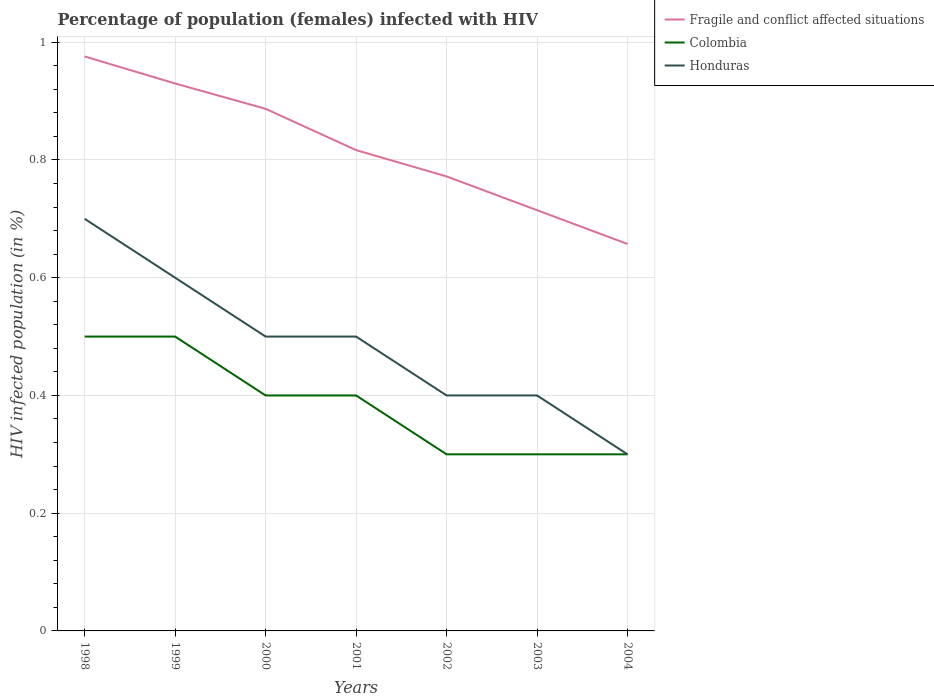Does the line corresponding to Fragile and conflict affected situations intersect with the line corresponding to Colombia?
Make the answer very short. No. Across all years, what is the maximum percentage of HIV infected female population in Colombia?
Keep it short and to the point. 0.3. What is the total percentage of HIV infected female population in Fragile and conflict affected situations in the graph?
Provide a succinct answer. 0.11. What is the difference between the highest and the second highest percentage of HIV infected female population in Honduras?
Your answer should be compact. 0.4. Is the percentage of HIV infected female population in Honduras strictly greater than the percentage of HIV infected female population in Fragile and conflict affected situations over the years?
Provide a short and direct response. Yes. How many lines are there?
Offer a very short reply. 3. How many years are there in the graph?
Make the answer very short. 7. What is the difference between two consecutive major ticks on the Y-axis?
Provide a succinct answer. 0.2. How many legend labels are there?
Offer a terse response. 3. What is the title of the graph?
Keep it short and to the point. Percentage of population (females) infected with HIV. Does "Vanuatu" appear as one of the legend labels in the graph?
Make the answer very short. No. What is the label or title of the Y-axis?
Provide a succinct answer. HIV infected population (in %). What is the HIV infected population (in %) in Fragile and conflict affected situations in 1998?
Your answer should be compact. 0.98. What is the HIV infected population (in %) in Colombia in 1998?
Your answer should be very brief. 0.5. What is the HIV infected population (in %) in Fragile and conflict affected situations in 1999?
Keep it short and to the point. 0.93. What is the HIV infected population (in %) in Colombia in 1999?
Give a very brief answer. 0.5. What is the HIV infected population (in %) in Honduras in 1999?
Make the answer very short. 0.6. What is the HIV infected population (in %) of Fragile and conflict affected situations in 2000?
Your response must be concise. 0.89. What is the HIV infected population (in %) in Colombia in 2000?
Give a very brief answer. 0.4. What is the HIV infected population (in %) in Honduras in 2000?
Ensure brevity in your answer.  0.5. What is the HIV infected population (in %) in Fragile and conflict affected situations in 2001?
Your answer should be compact. 0.82. What is the HIV infected population (in %) in Colombia in 2001?
Offer a very short reply. 0.4. What is the HIV infected population (in %) of Honduras in 2001?
Your answer should be compact. 0.5. What is the HIV infected population (in %) of Fragile and conflict affected situations in 2002?
Ensure brevity in your answer.  0.77. What is the HIV infected population (in %) of Colombia in 2002?
Give a very brief answer. 0.3. What is the HIV infected population (in %) in Honduras in 2002?
Offer a very short reply. 0.4. What is the HIV infected population (in %) of Fragile and conflict affected situations in 2003?
Your answer should be very brief. 0.71. What is the HIV infected population (in %) in Colombia in 2003?
Your response must be concise. 0.3. What is the HIV infected population (in %) in Honduras in 2003?
Make the answer very short. 0.4. What is the HIV infected population (in %) in Fragile and conflict affected situations in 2004?
Make the answer very short. 0.66. What is the HIV infected population (in %) of Honduras in 2004?
Offer a very short reply. 0.3. Across all years, what is the maximum HIV infected population (in %) in Fragile and conflict affected situations?
Offer a very short reply. 0.98. Across all years, what is the maximum HIV infected population (in %) of Colombia?
Offer a very short reply. 0.5. Across all years, what is the minimum HIV infected population (in %) of Fragile and conflict affected situations?
Your response must be concise. 0.66. Across all years, what is the minimum HIV infected population (in %) in Honduras?
Keep it short and to the point. 0.3. What is the total HIV infected population (in %) in Fragile and conflict affected situations in the graph?
Provide a short and direct response. 5.75. What is the total HIV infected population (in %) in Colombia in the graph?
Offer a very short reply. 2.7. What is the difference between the HIV infected population (in %) of Fragile and conflict affected situations in 1998 and that in 1999?
Make the answer very short. 0.05. What is the difference between the HIV infected population (in %) of Colombia in 1998 and that in 1999?
Your response must be concise. 0. What is the difference between the HIV infected population (in %) in Fragile and conflict affected situations in 1998 and that in 2000?
Ensure brevity in your answer.  0.09. What is the difference between the HIV infected population (in %) of Fragile and conflict affected situations in 1998 and that in 2001?
Provide a short and direct response. 0.16. What is the difference between the HIV infected population (in %) of Colombia in 1998 and that in 2001?
Make the answer very short. 0.1. What is the difference between the HIV infected population (in %) of Fragile and conflict affected situations in 1998 and that in 2002?
Offer a very short reply. 0.2. What is the difference between the HIV infected population (in %) of Fragile and conflict affected situations in 1998 and that in 2003?
Ensure brevity in your answer.  0.26. What is the difference between the HIV infected population (in %) in Fragile and conflict affected situations in 1998 and that in 2004?
Provide a succinct answer. 0.32. What is the difference between the HIV infected population (in %) of Colombia in 1998 and that in 2004?
Your answer should be compact. 0.2. What is the difference between the HIV infected population (in %) of Honduras in 1998 and that in 2004?
Keep it short and to the point. 0.4. What is the difference between the HIV infected population (in %) of Fragile and conflict affected situations in 1999 and that in 2000?
Ensure brevity in your answer.  0.04. What is the difference between the HIV infected population (in %) of Colombia in 1999 and that in 2000?
Provide a short and direct response. 0.1. What is the difference between the HIV infected population (in %) of Honduras in 1999 and that in 2000?
Provide a succinct answer. 0.1. What is the difference between the HIV infected population (in %) in Fragile and conflict affected situations in 1999 and that in 2001?
Provide a succinct answer. 0.11. What is the difference between the HIV infected population (in %) in Fragile and conflict affected situations in 1999 and that in 2002?
Offer a terse response. 0.16. What is the difference between the HIV infected population (in %) in Fragile and conflict affected situations in 1999 and that in 2003?
Provide a short and direct response. 0.22. What is the difference between the HIV infected population (in %) of Honduras in 1999 and that in 2003?
Your answer should be very brief. 0.2. What is the difference between the HIV infected population (in %) of Fragile and conflict affected situations in 1999 and that in 2004?
Your response must be concise. 0.27. What is the difference between the HIV infected population (in %) of Colombia in 1999 and that in 2004?
Provide a short and direct response. 0.2. What is the difference between the HIV infected population (in %) in Fragile and conflict affected situations in 2000 and that in 2001?
Provide a short and direct response. 0.07. What is the difference between the HIV infected population (in %) in Colombia in 2000 and that in 2001?
Offer a terse response. 0. What is the difference between the HIV infected population (in %) of Honduras in 2000 and that in 2001?
Make the answer very short. 0. What is the difference between the HIV infected population (in %) of Fragile and conflict affected situations in 2000 and that in 2002?
Give a very brief answer. 0.11. What is the difference between the HIV infected population (in %) of Fragile and conflict affected situations in 2000 and that in 2003?
Your response must be concise. 0.17. What is the difference between the HIV infected population (in %) of Honduras in 2000 and that in 2003?
Give a very brief answer. 0.1. What is the difference between the HIV infected population (in %) in Fragile and conflict affected situations in 2000 and that in 2004?
Offer a very short reply. 0.23. What is the difference between the HIV infected population (in %) in Fragile and conflict affected situations in 2001 and that in 2002?
Your answer should be very brief. 0.04. What is the difference between the HIV infected population (in %) of Honduras in 2001 and that in 2002?
Your answer should be very brief. 0.1. What is the difference between the HIV infected population (in %) of Fragile and conflict affected situations in 2001 and that in 2003?
Provide a succinct answer. 0.1. What is the difference between the HIV infected population (in %) of Honduras in 2001 and that in 2003?
Your answer should be compact. 0.1. What is the difference between the HIV infected population (in %) in Fragile and conflict affected situations in 2001 and that in 2004?
Keep it short and to the point. 0.16. What is the difference between the HIV infected population (in %) in Colombia in 2001 and that in 2004?
Make the answer very short. 0.1. What is the difference between the HIV infected population (in %) in Fragile and conflict affected situations in 2002 and that in 2003?
Give a very brief answer. 0.06. What is the difference between the HIV infected population (in %) in Colombia in 2002 and that in 2003?
Make the answer very short. 0. What is the difference between the HIV infected population (in %) of Fragile and conflict affected situations in 2002 and that in 2004?
Provide a short and direct response. 0.11. What is the difference between the HIV infected population (in %) of Colombia in 2002 and that in 2004?
Offer a terse response. 0. What is the difference between the HIV infected population (in %) in Honduras in 2002 and that in 2004?
Your response must be concise. 0.1. What is the difference between the HIV infected population (in %) in Fragile and conflict affected situations in 2003 and that in 2004?
Ensure brevity in your answer.  0.06. What is the difference between the HIV infected population (in %) of Fragile and conflict affected situations in 1998 and the HIV infected population (in %) of Colombia in 1999?
Provide a short and direct response. 0.48. What is the difference between the HIV infected population (in %) in Fragile and conflict affected situations in 1998 and the HIV infected population (in %) in Honduras in 1999?
Make the answer very short. 0.38. What is the difference between the HIV infected population (in %) of Colombia in 1998 and the HIV infected population (in %) of Honduras in 1999?
Provide a short and direct response. -0.1. What is the difference between the HIV infected population (in %) of Fragile and conflict affected situations in 1998 and the HIV infected population (in %) of Colombia in 2000?
Offer a very short reply. 0.58. What is the difference between the HIV infected population (in %) in Fragile and conflict affected situations in 1998 and the HIV infected population (in %) in Honduras in 2000?
Make the answer very short. 0.48. What is the difference between the HIV infected population (in %) of Fragile and conflict affected situations in 1998 and the HIV infected population (in %) of Colombia in 2001?
Your answer should be very brief. 0.58. What is the difference between the HIV infected population (in %) of Fragile and conflict affected situations in 1998 and the HIV infected population (in %) of Honduras in 2001?
Offer a terse response. 0.48. What is the difference between the HIV infected population (in %) of Colombia in 1998 and the HIV infected population (in %) of Honduras in 2001?
Give a very brief answer. 0. What is the difference between the HIV infected population (in %) in Fragile and conflict affected situations in 1998 and the HIV infected population (in %) in Colombia in 2002?
Offer a terse response. 0.68. What is the difference between the HIV infected population (in %) of Fragile and conflict affected situations in 1998 and the HIV infected population (in %) of Honduras in 2002?
Keep it short and to the point. 0.58. What is the difference between the HIV infected population (in %) in Fragile and conflict affected situations in 1998 and the HIV infected population (in %) in Colombia in 2003?
Your answer should be compact. 0.68. What is the difference between the HIV infected population (in %) in Fragile and conflict affected situations in 1998 and the HIV infected population (in %) in Honduras in 2003?
Keep it short and to the point. 0.58. What is the difference between the HIV infected population (in %) of Fragile and conflict affected situations in 1998 and the HIV infected population (in %) of Colombia in 2004?
Ensure brevity in your answer.  0.68. What is the difference between the HIV infected population (in %) of Fragile and conflict affected situations in 1998 and the HIV infected population (in %) of Honduras in 2004?
Your answer should be compact. 0.68. What is the difference between the HIV infected population (in %) of Fragile and conflict affected situations in 1999 and the HIV infected population (in %) of Colombia in 2000?
Provide a short and direct response. 0.53. What is the difference between the HIV infected population (in %) in Fragile and conflict affected situations in 1999 and the HIV infected population (in %) in Honduras in 2000?
Your response must be concise. 0.43. What is the difference between the HIV infected population (in %) of Fragile and conflict affected situations in 1999 and the HIV infected population (in %) of Colombia in 2001?
Your response must be concise. 0.53. What is the difference between the HIV infected population (in %) of Fragile and conflict affected situations in 1999 and the HIV infected population (in %) of Honduras in 2001?
Your answer should be very brief. 0.43. What is the difference between the HIV infected population (in %) of Fragile and conflict affected situations in 1999 and the HIV infected population (in %) of Colombia in 2002?
Provide a short and direct response. 0.63. What is the difference between the HIV infected population (in %) of Fragile and conflict affected situations in 1999 and the HIV infected population (in %) of Honduras in 2002?
Keep it short and to the point. 0.53. What is the difference between the HIV infected population (in %) in Fragile and conflict affected situations in 1999 and the HIV infected population (in %) in Colombia in 2003?
Your answer should be very brief. 0.63. What is the difference between the HIV infected population (in %) of Fragile and conflict affected situations in 1999 and the HIV infected population (in %) of Honduras in 2003?
Provide a succinct answer. 0.53. What is the difference between the HIV infected population (in %) in Colombia in 1999 and the HIV infected population (in %) in Honduras in 2003?
Your answer should be compact. 0.1. What is the difference between the HIV infected population (in %) in Fragile and conflict affected situations in 1999 and the HIV infected population (in %) in Colombia in 2004?
Keep it short and to the point. 0.63. What is the difference between the HIV infected population (in %) in Fragile and conflict affected situations in 1999 and the HIV infected population (in %) in Honduras in 2004?
Keep it short and to the point. 0.63. What is the difference between the HIV infected population (in %) of Fragile and conflict affected situations in 2000 and the HIV infected population (in %) of Colombia in 2001?
Offer a very short reply. 0.49. What is the difference between the HIV infected population (in %) of Fragile and conflict affected situations in 2000 and the HIV infected population (in %) of Honduras in 2001?
Provide a succinct answer. 0.39. What is the difference between the HIV infected population (in %) of Colombia in 2000 and the HIV infected population (in %) of Honduras in 2001?
Provide a short and direct response. -0.1. What is the difference between the HIV infected population (in %) of Fragile and conflict affected situations in 2000 and the HIV infected population (in %) of Colombia in 2002?
Provide a succinct answer. 0.59. What is the difference between the HIV infected population (in %) in Fragile and conflict affected situations in 2000 and the HIV infected population (in %) in Honduras in 2002?
Your answer should be very brief. 0.49. What is the difference between the HIV infected population (in %) in Fragile and conflict affected situations in 2000 and the HIV infected population (in %) in Colombia in 2003?
Offer a terse response. 0.59. What is the difference between the HIV infected population (in %) of Fragile and conflict affected situations in 2000 and the HIV infected population (in %) of Honduras in 2003?
Provide a short and direct response. 0.49. What is the difference between the HIV infected population (in %) of Fragile and conflict affected situations in 2000 and the HIV infected population (in %) of Colombia in 2004?
Your response must be concise. 0.59. What is the difference between the HIV infected population (in %) of Fragile and conflict affected situations in 2000 and the HIV infected population (in %) of Honduras in 2004?
Offer a terse response. 0.59. What is the difference between the HIV infected population (in %) in Colombia in 2000 and the HIV infected population (in %) in Honduras in 2004?
Your response must be concise. 0.1. What is the difference between the HIV infected population (in %) of Fragile and conflict affected situations in 2001 and the HIV infected population (in %) of Colombia in 2002?
Ensure brevity in your answer.  0.52. What is the difference between the HIV infected population (in %) of Fragile and conflict affected situations in 2001 and the HIV infected population (in %) of Honduras in 2002?
Give a very brief answer. 0.42. What is the difference between the HIV infected population (in %) of Colombia in 2001 and the HIV infected population (in %) of Honduras in 2002?
Provide a succinct answer. 0. What is the difference between the HIV infected population (in %) in Fragile and conflict affected situations in 2001 and the HIV infected population (in %) in Colombia in 2003?
Offer a very short reply. 0.52. What is the difference between the HIV infected population (in %) of Fragile and conflict affected situations in 2001 and the HIV infected population (in %) of Honduras in 2003?
Provide a succinct answer. 0.42. What is the difference between the HIV infected population (in %) in Fragile and conflict affected situations in 2001 and the HIV infected population (in %) in Colombia in 2004?
Your answer should be very brief. 0.52. What is the difference between the HIV infected population (in %) in Fragile and conflict affected situations in 2001 and the HIV infected population (in %) in Honduras in 2004?
Ensure brevity in your answer.  0.52. What is the difference between the HIV infected population (in %) of Fragile and conflict affected situations in 2002 and the HIV infected population (in %) of Colombia in 2003?
Your answer should be compact. 0.47. What is the difference between the HIV infected population (in %) in Fragile and conflict affected situations in 2002 and the HIV infected population (in %) in Honduras in 2003?
Give a very brief answer. 0.37. What is the difference between the HIV infected population (in %) of Fragile and conflict affected situations in 2002 and the HIV infected population (in %) of Colombia in 2004?
Give a very brief answer. 0.47. What is the difference between the HIV infected population (in %) in Fragile and conflict affected situations in 2002 and the HIV infected population (in %) in Honduras in 2004?
Your response must be concise. 0.47. What is the difference between the HIV infected population (in %) of Fragile and conflict affected situations in 2003 and the HIV infected population (in %) of Colombia in 2004?
Keep it short and to the point. 0.41. What is the difference between the HIV infected population (in %) in Fragile and conflict affected situations in 2003 and the HIV infected population (in %) in Honduras in 2004?
Provide a succinct answer. 0.41. What is the average HIV infected population (in %) in Fragile and conflict affected situations per year?
Make the answer very short. 0.82. What is the average HIV infected population (in %) of Colombia per year?
Ensure brevity in your answer.  0.39. What is the average HIV infected population (in %) in Honduras per year?
Offer a very short reply. 0.49. In the year 1998, what is the difference between the HIV infected population (in %) of Fragile and conflict affected situations and HIV infected population (in %) of Colombia?
Provide a succinct answer. 0.48. In the year 1998, what is the difference between the HIV infected population (in %) in Fragile and conflict affected situations and HIV infected population (in %) in Honduras?
Your response must be concise. 0.28. In the year 1999, what is the difference between the HIV infected population (in %) of Fragile and conflict affected situations and HIV infected population (in %) of Colombia?
Give a very brief answer. 0.43. In the year 1999, what is the difference between the HIV infected population (in %) in Fragile and conflict affected situations and HIV infected population (in %) in Honduras?
Your answer should be compact. 0.33. In the year 1999, what is the difference between the HIV infected population (in %) of Colombia and HIV infected population (in %) of Honduras?
Give a very brief answer. -0.1. In the year 2000, what is the difference between the HIV infected population (in %) in Fragile and conflict affected situations and HIV infected population (in %) in Colombia?
Your response must be concise. 0.49. In the year 2000, what is the difference between the HIV infected population (in %) of Fragile and conflict affected situations and HIV infected population (in %) of Honduras?
Keep it short and to the point. 0.39. In the year 2001, what is the difference between the HIV infected population (in %) in Fragile and conflict affected situations and HIV infected population (in %) in Colombia?
Your answer should be very brief. 0.42. In the year 2001, what is the difference between the HIV infected population (in %) in Fragile and conflict affected situations and HIV infected population (in %) in Honduras?
Offer a very short reply. 0.32. In the year 2001, what is the difference between the HIV infected population (in %) in Colombia and HIV infected population (in %) in Honduras?
Ensure brevity in your answer.  -0.1. In the year 2002, what is the difference between the HIV infected population (in %) in Fragile and conflict affected situations and HIV infected population (in %) in Colombia?
Offer a terse response. 0.47. In the year 2002, what is the difference between the HIV infected population (in %) in Fragile and conflict affected situations and HIV infected population (in %) in Honduras?
Offer a very short reply. 0.37. In the year 2002, what is the difference between the HIV infected population (in %) in Colombia and HIV infected population (in %) in Honduras?
Your response must be concise. -0.1. In the year 2003, what is the difference between the HIV infected population (in %) in Fragile and conflict affected situations and HIV infected population (in %) in Colombia?
Your answer should be compact. 0.41. In the year 2003, what is the difference between the HIV infected population (in %) in Fragile and conflict affected situations and HIV infected population (in %) in Honduras?
Your response must be concise. 0.31. In the year 2003, what is the difference between the HIV infected population (in %) of Colombia and HIV infected population (in %) of Honduras?
Your answer should be compact. -0.1. In the year 2004, what is the difference between the HIV infected population (in %) of Fragile and conflict affected situations and HIV infected population (in %) of Colombia?
Give a very brief answer. 0.36. In the year 2004, what is the difference between the HIV infected population (in %) in Fragile and conflict affected situations and HIV infected population (in %) in Honduras?
Ensure brevity in your answer.  0.36. In the year 2004, what is the difference between the HIV infected population (in %) of Colombia and HIV infected population (in %) of Honduras?
Keep it short and to the point. 0. What is the ratio of the HIV infected population (in %) of Fragile and conflict affected situations in 1998 to that in 1999?
Your answer should be very brief. 1.05. What is the ratio of the HIV infected population (in %) of Colombia in 1998 to that in 1999?
Your response must be concise. 1. What is the ratio of the HIV infected population (in %) in Fragile and conflict affected situations in 1998 to that in 2000?
Give a very brief answer. 1.1. What is the ratio of the HIV infected population (in %) of Colombia in 1998 to that in 2000?
Offer a very short reply. 1.25. What is the ratio of the HIV infected population (in %) in Honduras in 1998 to that in 2000?
Provide a short and direct response. 1.4. What is the ratio of the HIV infected population (in %) of Fragile and conflict affected situations in 1998 to that in 2001?
Provide a short and direct response. 1.19. What is the ratio of the HIV infected population (in %) of Colombia in 1998 to that in 2001?
Your answer should be very brief. 1.25. What is the ratio of the HIV infected population (in %) of Fragile and conflict affected situations in 1998 to that in 2002?
Provide a succinct answer. 1.26. What is the ratio of the HIV infected population (in %) in Fragile and conflict affected situations in 1998 to that in 2003?
Your answer should be very brief. 1.37. What is the ratio of the HIV infected population (in %) of Fragile and conflict affected situations in 1998 to that in 2004?
Give a very brief answer. 1.48. What is the ratio of the HIV infected population (in %) of Honduras in 1998 to that in 2004?
Offer a very short reply. 2.33. What is the ratio of the HIV infected population (in %) in Fragile and conflict affected situations in 1999 to that in 2000?
Make the answer very short. 1.05. What is the ratio of the HIV infected population (in %) of Fragile and conflict affected situations in 1999 to that in 2001?
Give a very brief answer. 1.14. What is the ratio of the HIV infected population (in %) of Colombia in 1999 to that in 2001?
Provide a succinct answer. 1.25. What is the ratio of the HIV infected population (in %) of Honduras in 1999 to that in 2001?
Keep it short and to the point. 1.2. What is the ratio of the HIV infected population (in %) in Fragile and conflict affected situations in 1999 to that in 2002?
Provide a succinct answer. 1.2. What is the ratio of the HIV infected population (in %) of Honduras in 1999 to that in 2002?
Your answer should be compact. 1.5. What is the ratio of the HIV infected population (in %) in Fragile and conflict affected situations in 1999 to that in 2003?
Your answer should be compact. 1.3. What is the ratio of the HIV infected population (in %) of Colombia in 1999 to that in 2003?
Your response must be concise. 1.67. What is the ratio of the HIV infected population (in %) of Honduras in 1999 to that in 2003?
Your response must be concise. 1.5. What is the ratio of the HIV infected population (in %) of Fragile and conflict affected situations in 1999 to that in 2004?
Ensure brevity in your answer.  1.41. What is the ratio of the HIV infected population (in %) in Honduras in 1999 to that in 2004?
Make the answer very short. 2. What is the ratio of the HIV infected population (in %) in Fragile and conflict affected situations in 2000 to that in 2001?
Offer a very short reply. 1.09. What is the ratio of the HIV infected population (in %) in Colombia in 2000 to that in 2001?
Provide a short and direct response. 1. What is the ratio of the HIV infected population (in %) in Fragile and conflict affected situations in 2000 to that in 2002?
Provide a short and direct response. 1.15. What is the ratio of the HIV infected population (in %) of Colombia in 2000 to that in 2002?
Your answer should be very brief. 1.33. What is the ratio of the HIV infected population (in %) in Honduras in 2000 to that in 2002?
Your answer should be very brief. 1.25. What is the ratio of the HIV infected population (in %) in Fragile and conflict affected situations in 2000 to that in 2003?
Make the answer very short. 1.24. What is the ratio of the HIV infected population (in %) in Colombia in 2000 to that in 2003?
Your answer should be compact. 1.33. What is the ratio of the HIV infected population (in %) in Honduras in 2000 to that in 2003?
Make the answer very short. 1.25. What is the ratio of the HIV infected population (in %) in Fragile and conflict affected situations in 2000 to that in 2004?
Give a very brief answer. 1.35. What is the ratio of the HIV infected population (in %) in Fragile and conflict affected situations in 2001 to that in 2002?
Offer a terse response. 1.06. What is the ratio of the HIV infected population (in %) in Fragile and conflict affected situations in 2001 to that in 2003?
Keep it short and to the point. 1.14. What is the ratio of the HIV infected population (in %) of Fragile and conflict affected situations in 2001 to that in 2004?
Make the answer very short. 1.24. What is the ratio of the HIV infected population (in %) of Honduras in 2001 to that in 2004?
Offer a terse response. 1.67. What is the ratio of the HIV infected population (in %) of Fragile and conflict affected situations in 2002 to that in 2003?
Your answer should be very brief. 1.08. What is the ratio of the HIV infected population (in %) in Honduras in 2002 to that in 2003?
Offer a terse response. 1. What is the ratio of the HIV infected population (in %) in Fragile and conflict affected situations in 2002 to that in 2004?
Your answer should be very brief. 1.17. What is the ratio of the HIV infected population (in %) of Colombia in 2002 to that in 2004?
Your answer should be very brief. 1. What is the ratio of the HIV infected population (in %) of Fragile and conflict affected situations in 2003 to that in 2004?
Your response must be concise. 1.09. What is the ratio of the HIV infected population (in %) of Honduras in 2003 to that in 2004?
Your answer should be compact. 1.33. What is the difference between the highest and the second highest HIV infected population (in %) of Fragile and conflict affected situations?
Your answer should be very brief. 0.05. What is the difference between the highest and the second highest HIV infected population (in %) of Honduras?
Ensure brevity in your answer.  0.1. What is the difference between the highest and the lowest HIV infected population (in %) in Fragile and conflict affected situations?
Your response must be concise. 0.32. What is the difference between the highest and the lowest HIV infected population (in %) of Honduras?
Your response must be concise. 0.4. 